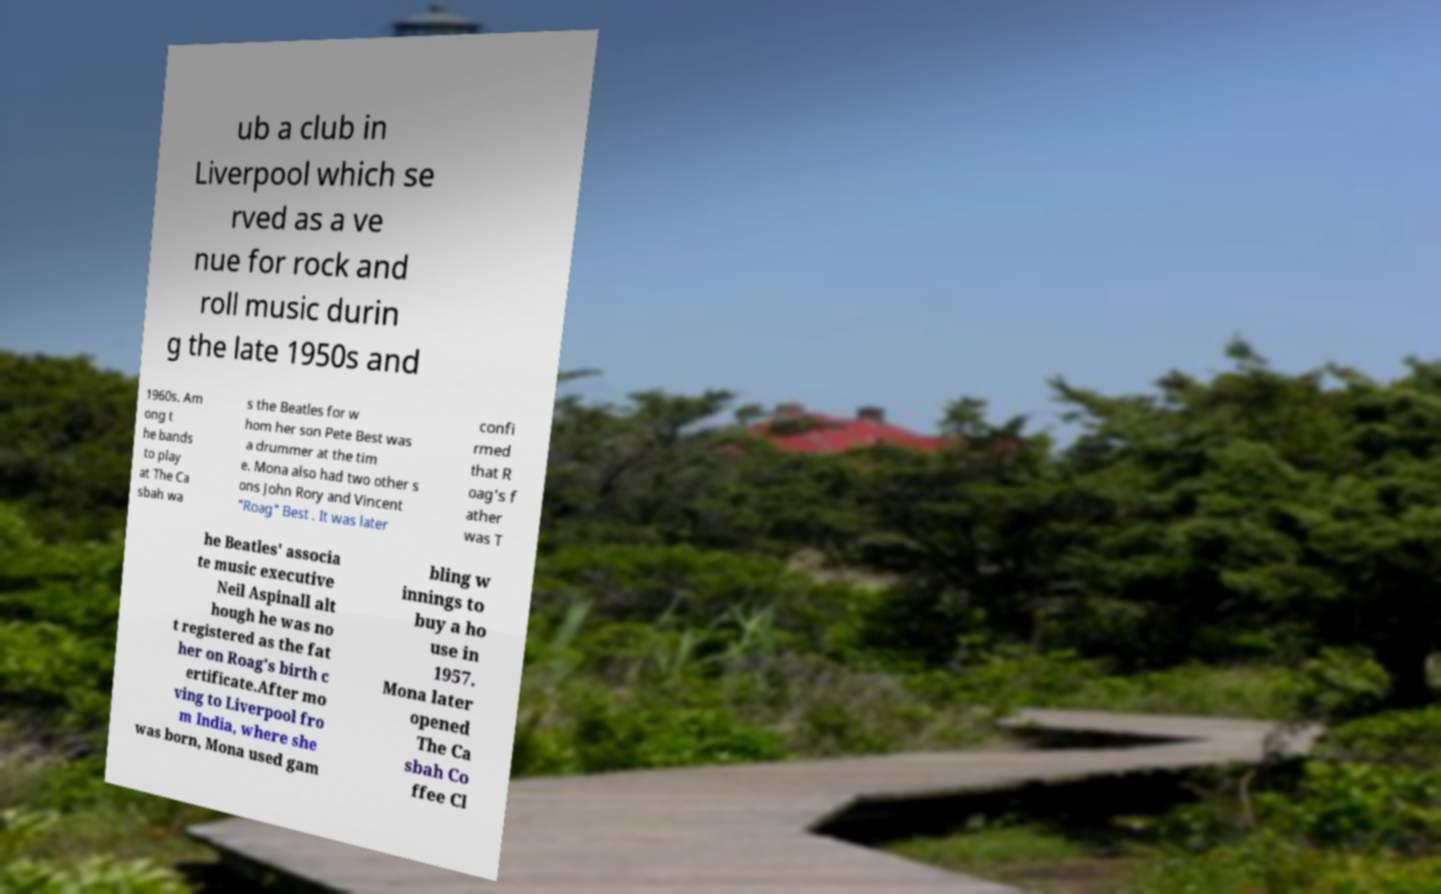Can you accurately transcribe the text from the provided image for me? ub a club in Liverpool which se rved as a ve nue for rock and roll music durin g the late 1950s and 1960s. Am ong t he bands to play at The Ca sbah wa s the Beatles for w hom her son Pete Best was a drummer at the tim e. Mona also had two other s ons John Rory and Vincent "Roag" Best . It was later confi rmed that R oag's f ather was T he Beatles' associa te music executive Neil Aspinall alt hough he was no t registered as the fat her on Roag's birth c ertificate.After mo ving to Liverpool fro m India, where she was born, Mona used gam bling w innings to buy a ho use in 1957. Mona later opened The Ca sbah Co ffee Cl 